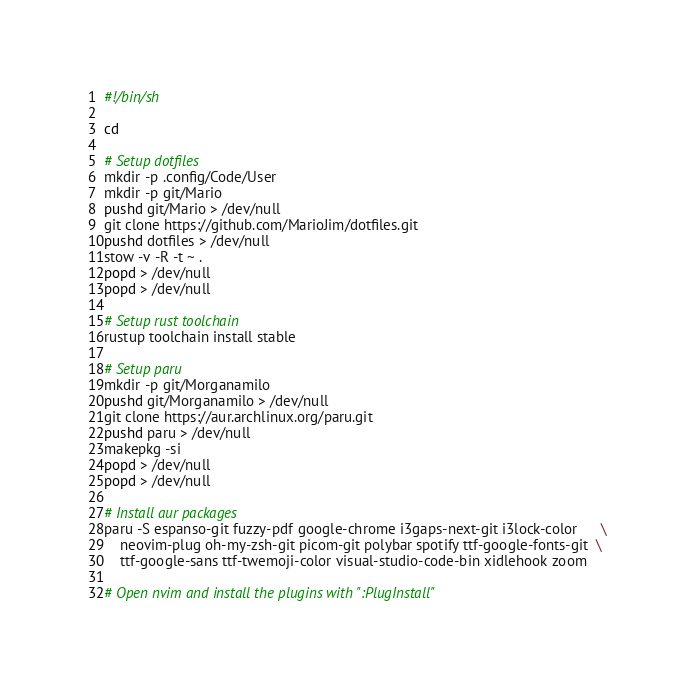<code> <loc_0><loc_0><loc_500><loc_500><_Bash_>#!/bin/sh

cd

# Setup dotfiles
mkdir -p .config/Code/User
mkdir -p git/Mario
pushd git/Mario > /dev/null
git clone https://github.com/MarioJim/dotfiles.git
pushd dotfiles > /dev/null
stow -v -R -t ~ .
popd > /dev/null
popd > /dev/null

# Setup rust toolchain
rustup toolchain install stable

# Setup paru
mkdir -p git/Morganamilo
pushd git/Morganamilo > /dev/null
git clone https://aur.archlinux.org/paru.git
pushd paru > /dev/null
makepkg -si
popd > /dev/null
popd > /dev/null

# Install aur packages
paru -S espanso-git fuzzy-pdf google-chrome i3gaps-next-git i3lock-color      \
    neovim-plug oh-my-zsh-git picom-git polybar spotify ttf-google-fonts-git  \
    ttf-google-sans ttf-twemoji-color visual-studio-code-bin xidlehook zoom

# Open nvim and install the plugins with ":PlugInstall"
</code> 